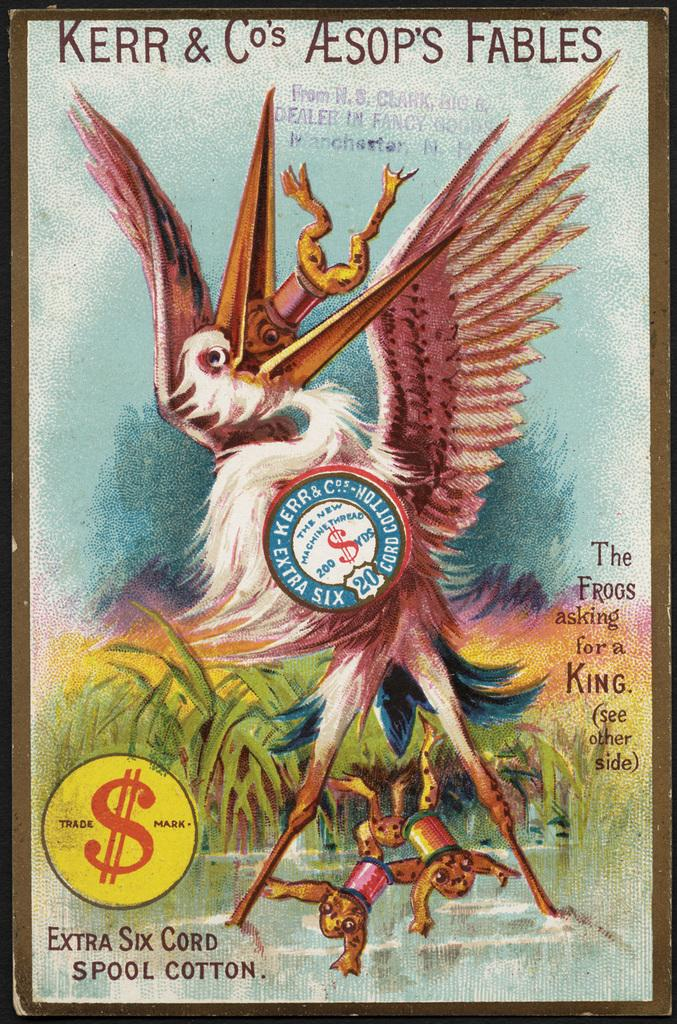<image>
Give a short and clear explanation of the subsequent image. A book of Aesop's Fables shows a heron eating a frog. 